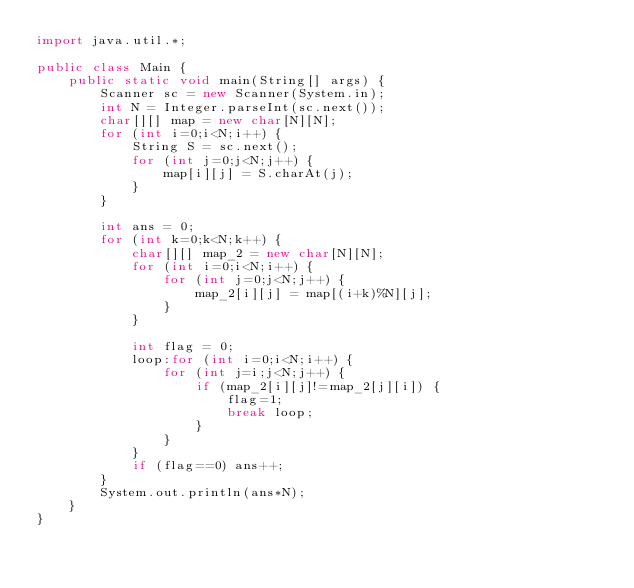<code> <loc_0><loc_0><loc_500><loc_500><_Java_>import java.util.*;

public class Main {
    public static void main(String[] args) {
        Scanner sc = new Scanner(System.in);
        int N = Integer.parseInt(sc.next());
        char[][] map = new char[N][N];
        for (int i=0;i<N;i++) {
            String S = sc.next();
            for (int j=0;j<N;j++) {
                map[i][j] = S.charAt(j);
            }
        }

        int ans = 0;
        for (int k=0;k<N;k++) {
            char[][] map_2 = new char[N][N];
            for (int i=0;i<N;i++) {
                for (int j=0;j<N;j++) {
                    map_2[i][j] = map[(i+k)%N][j];
                }
            }

            int flag = 0;
            loop:for (int i=0;i<N;i++) {
                for (int j=i;j<N;j++) {
                    if (map_2[i][j]!=map_2[j][i]) {
                        flag=1;
                        break loop;
                    }
                }
            }
            if (flag==0) ans++;
        }
        System.out.println(ans*N);
    }
}</code> 